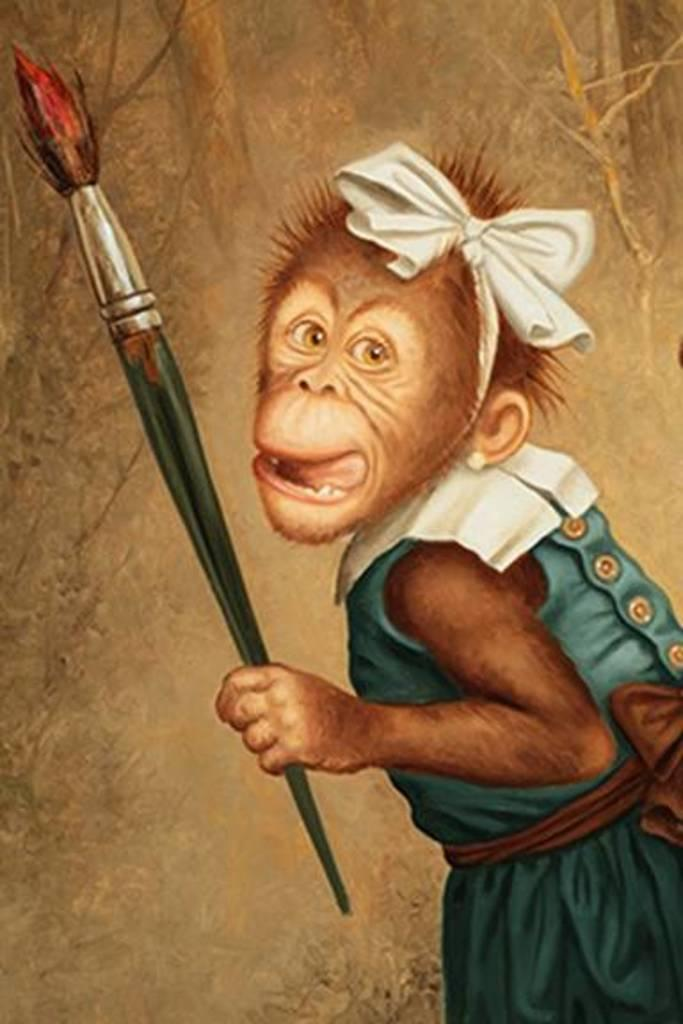What is depicted in the painting in the image? The painting contains a monkey. What is the monkey wearing in the painting? The monkey is wearing a blue dress in the painting. What is the monkey holding in the painting? The monkey is holding a painting brush in the painting. What color is the background of the painting? The background of the painting is blue. How many bears are visible on the plate in the image? There are no bears or plates present in the image; it features a painting of a monkey. What type of roll is being used by the monkey in the image? There is no roll present in the image; the monkey is holding a painting brush. 